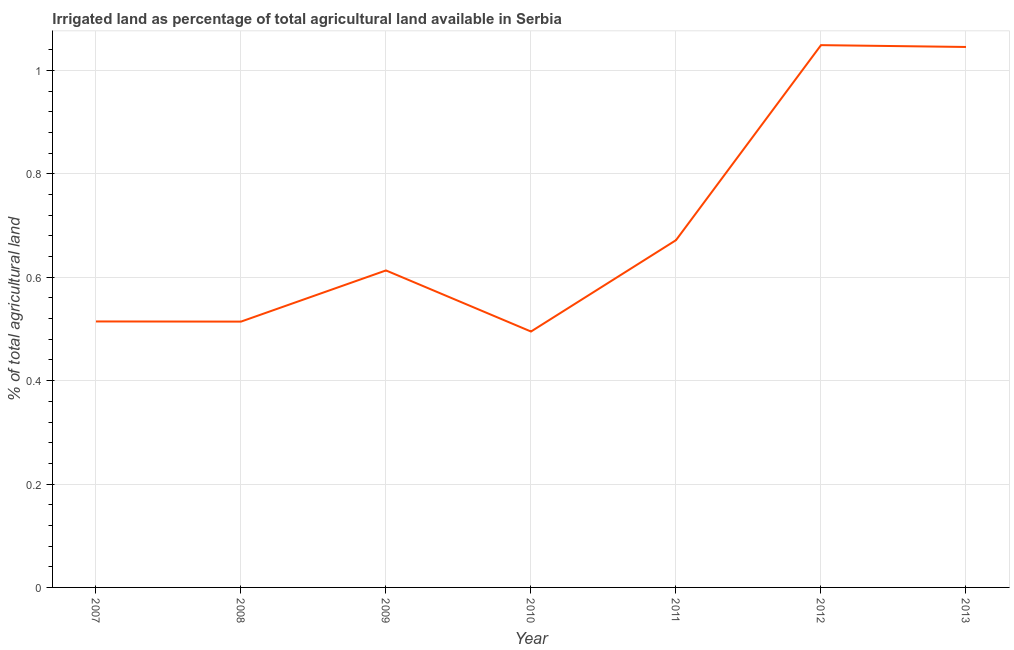What is the percentage of agricultural irrigated land in 2008?
Offer a terse response. 0.51. Across all years, what is the maximum percentage of agricultural irrigated land?
Ensure brevity in your answer.  1.05. Across all years, what is the minimum percentage of agricultural irrigated land?
Provide a succinct answer. 0.5. What is the sum of the percentage of agricultural irrigated land?
Offer a terse response. 4.9. What is the difference between the percentage of agricultural irrigated land in 2007 and 2011?
Offer a terse response. -0.16. What is the average percentage of agricultural irrigated land per year?
Provide a succinct answer. 0.7. What is the median percentage of agricultural irrigated land?
Your response must be concise. 0.61. What is the ratio of the percentage of agricultural irrigated land in 2008 to that in 2011?
Your answer should be very brief. 0.77. What is the difference between the highest and the second highest percentage of agricultural irrigated land?
Offer a very short reply. 0. Is the sum of the percentage of agricultural irrigated land in 2011 and 2012 greater than the maximum percentage of agricultural irrigated land across all years?
Your answer should be very brief. Yes. What is the difference between the highest and the lowest percentage of agricultural irrigated land?
Provide a short and direct response. 0.55. How many lines are there?
Offer a terse response. 1. What is the title of the graph?
Your response must be concise. Irrigated land as percentage of total agricultural land available in Serbia. What is the label or title of the X-axis?
Provide a succinct answer. Year. What is the label or title of the Y-axis?
Ensure brevity in your answer.  % of total agricultural land. What is the % of total agricultural land of 2007?
Offer a terse response. 0.51. What is the % of total agricultural land of 2008?
Your response must be concise. 0.51. What is the % of total agricultural land of 2009?
Offer a very short reply. 0.61. What is the % of total agricultural land in 2010?
Offer a terse response. 0.5. What is the % of total agricultural land in 2011?
Ensure brevity in your answer.  0.67. What is the % of total agricultural land of 2012?
Make the answer very short. 1.05. What is the % of total agricultural land in 2013?
Make the answer very short. 1.05. What is the difference between the % of total agricultural land in 2007 and 2008?
Offer a very short reply. 0. What is the difference between the % of total agricultural land in 2007 and 2009?
Offer a very short reply. -0.1. What is the difference between the % of total agricultural land in 2007 and 2010?
Your answer should be very brief. 0.02. What is the difference between the % of total agricultural land in 2007 and 2011?
Offer a terse response. -0.16. What is the difference between the % of total agricultural land in 2007 and 2012?
Provide a succinct answer. -0.53. What is the difference between the % of total agricultural land in 2007 and 2013?
Your answer should be very brief. -0.53. What is the difference between the % of total agricultural land in 2008 and 2009?
Your answer should be very brief. -0.1. What is the difference between the % of total agricultural land in 2008 and 2010?
Keep it short and to the point. 0.02. What is the difference between the % of total agricultural land in 2008 and 2011?
Make the answer very short. -0.16. What is the difference between the % of total agricultural land in 2008 and 2012?
Give a very brief answer. -0.53. What is the difference between the % of total agricultural land in 2008 and 2013?
Your answer should be very brief. -0.53. What is the difference between the % of total agricultural land in 2009 and 2010?
Provide a succinct answer. 0.12. What is the difference between the % of total agricultural land in 2009 and 2011?
Your answer should be very brief. -0.06. What is the difference between the % of total agricultural land in 2009 and 2012?
Give a very brief answer. -0.44. What is the difference between the % of total agricultural land in 2009 and 2013?
Provide a succinct answer. -0.43. What is the difference between the % of total agricultural land in 2010 and 2011?
Ensure brevity in your answer.  -0.18. What is the difference between the % of total agricultural land in 2010 and 2012?
Make the answer very short. -0.55. What is the difference between the % of total agricultural land in 2010 and 2013?
Give a very brief answer. -0.55. What is the difference between the % of total agricultural land in 2011 and 2012?
Make the answer very short. -0.38. What is the difference between the % of total agricultural land in 2011 and 2013?
Offer a terse response. -0.37. What is the difference between the % of total agricultural land in 2012 and 2013?
Provide a short and direct response. 0. What is the ratio of the % of total agricultural land in 2007 to that in 2008?
Your answer should be compact. 1. What is the ratio of the % of total agricultural land in 2007 to that in 2009?
Offer a very short reply. 0.84. What is the ratio of the % of total agricultural land in 2007 to that in 2010?
Your answer should be very brief. 1.04. What is the ratio of the % of total agricultural land in 2007 to that in 2011?
Ensure brevity in your answer.  0.77. What is the ratio of the % of total agricultural land in 2007 to that in 2012?
Your answer should be very brief. 0.49. What is the ratio of the % of total agricultural land in 2007 to that in 2013?
Keep it short and to the point. 0.49. What is the ratio of the % of total agricultural land in 2008 to that in 2009?
Make the answer very short. 0.84. What is the ratio of the % of total agricultural land in 2008 to that in 2010?
Give a very brief answer. 1.04. What is the ratio of the % of total agricultural land in 2008 to that in 2011?
Offer a very short reply. 0.77. What is the ratio of the % of total agricultural land in 2008 to that in 2012?
Make the answer very short. 0.49. What is the ratio of the % of total agricultural land in 2008 to that in 2013?
Your answer should be very brief. 0.49. What is the ratio of the % of total agricultural land in 2009 to that in 2010?
Your answer should be very brief. 1.24. What is the ratio of the % of total agricultural land in 2009 to that in 2011?
Make the answer very short. 0.91. What is the ratio of the % of total agricultural land in 2009 to that in 2012?
Provide a succinct answer. 0.58. What is the ratio of the % of total agricultural land in 2009 to that in 2013?
Offer a terse response. 0.59. What is the ratio of the % of total agricultural land in 2010 to that in 2011?
Offer a terse response. 0.74. What is the ratio of the % of total agricultural land in 2010 to that in 2012?
Your answer should be compact. 0.47. What is the ratio of the % of total agricultural land in 2010 to that in 2013?
Your answer should be compact. 0.47. What is the ratio of the % of total agricultural land in 2011 to that in 2012?
Your answer should be very brief. 0.64. What is the ratio of the % of total agricultural land in 2011 to that in 2013?
Ensure brevity in your answer.  0.64. 